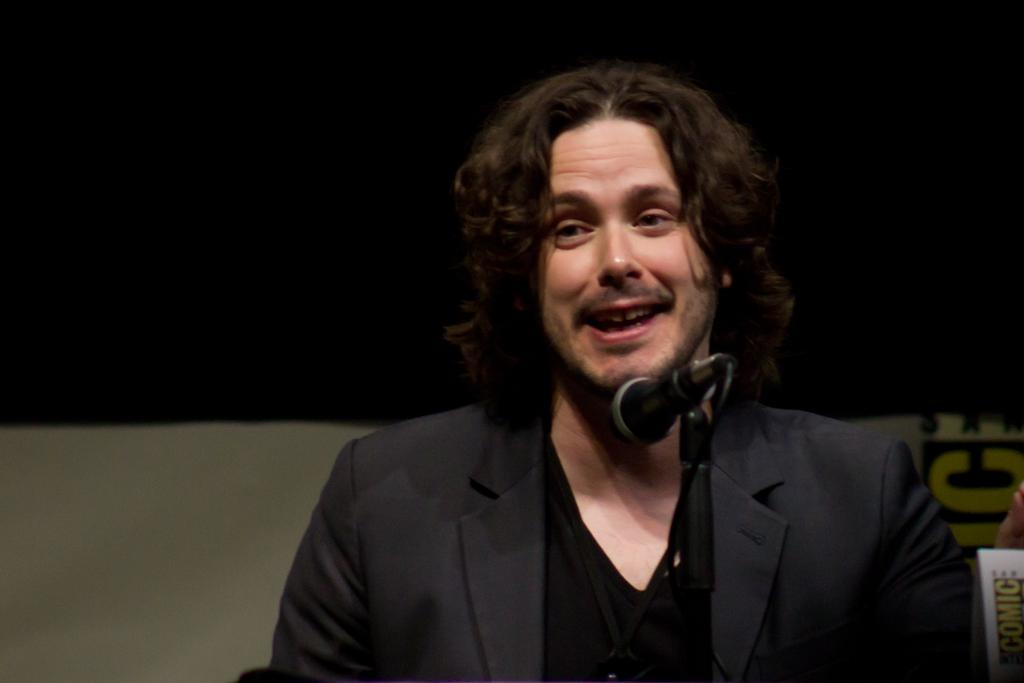Who is present in the image? There is a man in the image. What is the man wearing? The man is wearing a black suit. What is the man doing in the image? The man is standing in front of a microphone. What type of bat is hanging from the microphone in the image? There is no bat present in the image; the man is standing in front of a microphone. What type of crib is visible in the background of the image? There is no crib present in the image; the man is standing in front of a microphone. 